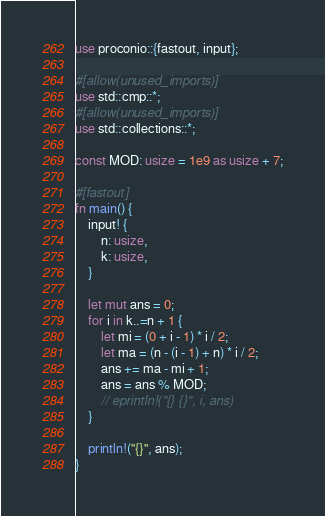<code> <loc_0><loc_0><loc_500><loc_500><_Rust_>use proconio::{fastout, input};

#[allow(unused_imports)]
use std::cmp::*;
#[allow(unused_imports)]
use std::collections::*;

const MOD: usize = 1e9 as usize + 7;

#[fastout]
fn main() {
    input! {
        n: usize,
        k: usize,
    }

    let mut ans = 0;
    for i in k..=n + 1 {
        let mi = (0 + i - 1) * i / 2;
        let ma = (n - (i - 1) + n) * i / 2;
        ans += ma - mi + 1;
        ans = ans % MOD;
        // eprintln!("{} {}", i, ans)
    }

    println!("{}", ans);
}
</code> 